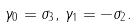<formula> <loc_0><loc_0><loc_500><loc_500>\gamma _ { 0 } = \sigma _ { 3 } , \, \gamma _ { 1 } = - \sigma _ { 2 } .</formula> 